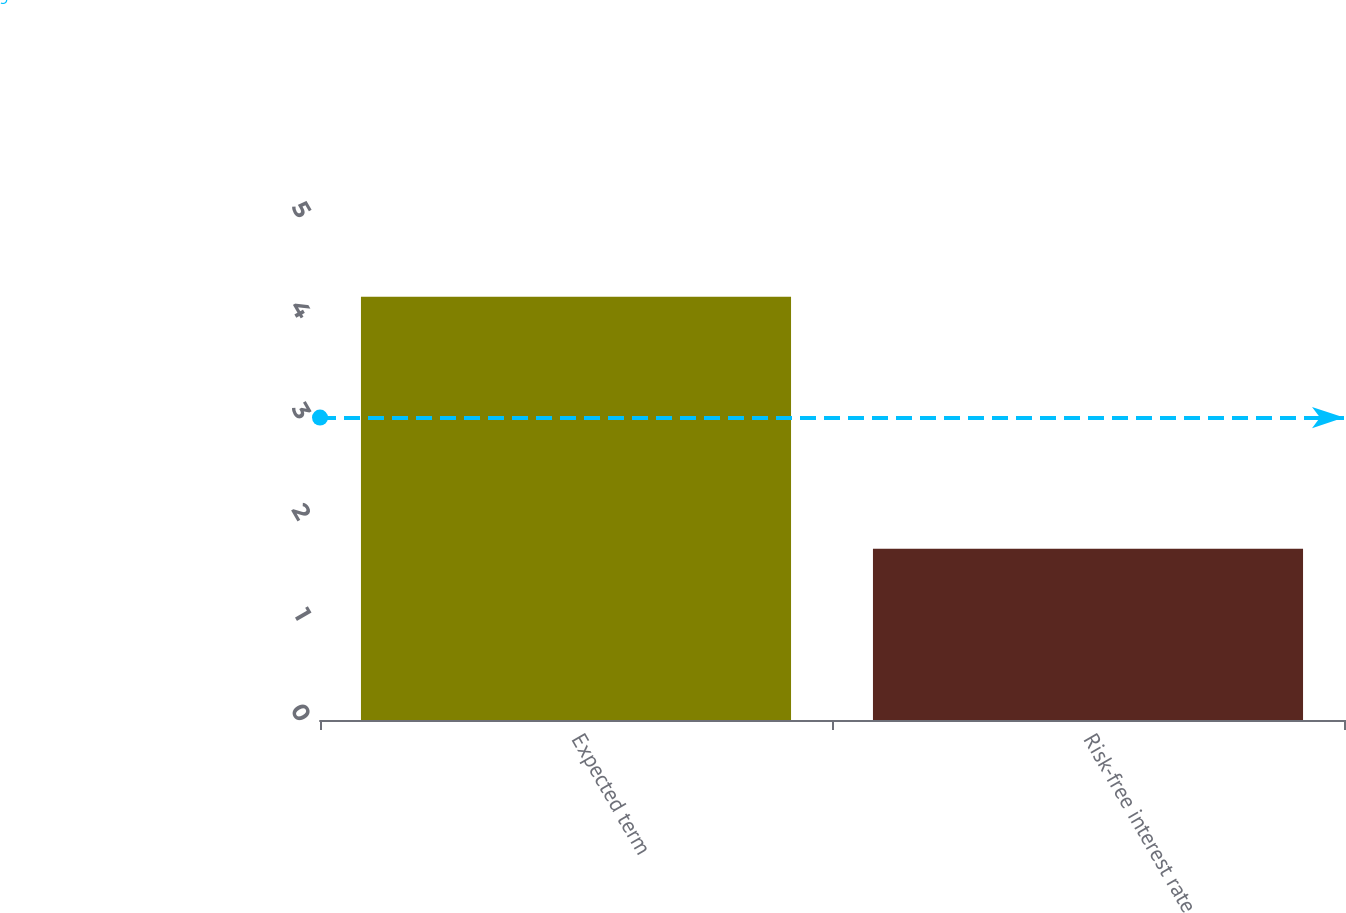Convert chart to OTSL. <chart><loc_0><loc_0><loc_500><loc_500><bar_chart><fcel>Expected term<fcel>Risk-free interest rate<nl><fcel>4.2<fcel>1.7<nl></chart> 